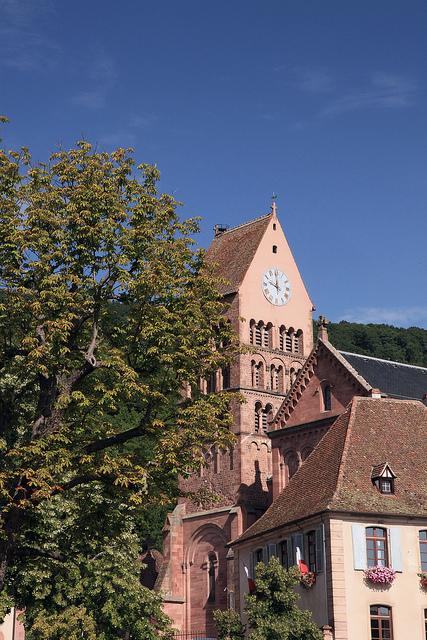Is this a church?
Answer briefly. Yes. How many clocks in this photo?
Short answer required. 1. What time does the clock say?
Write a very short answer. 11:00. What material are the buildings made of?
Be succinct. Brick. What time is it?
Short answer required. 10:00. Can the tree tell time?
Keep it brief. No. What time is on the clock?
Concise answer only. 10:00. 